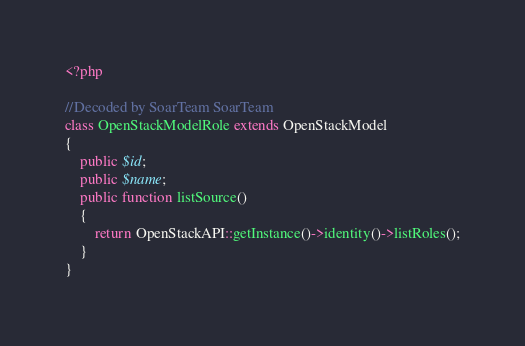<code> <loc_0><loc_0><loc_500><loc_500><_PHP_><?php

//Decoded by SoarTeam SoarTeam
class OpenStackModelRole extends OpenStackModel
{
	public $id;
	public $name;
	public function listSource()
	{
		return OpenStackAPI::getInstance()->identity()->listRoles();
	}
}</code> 